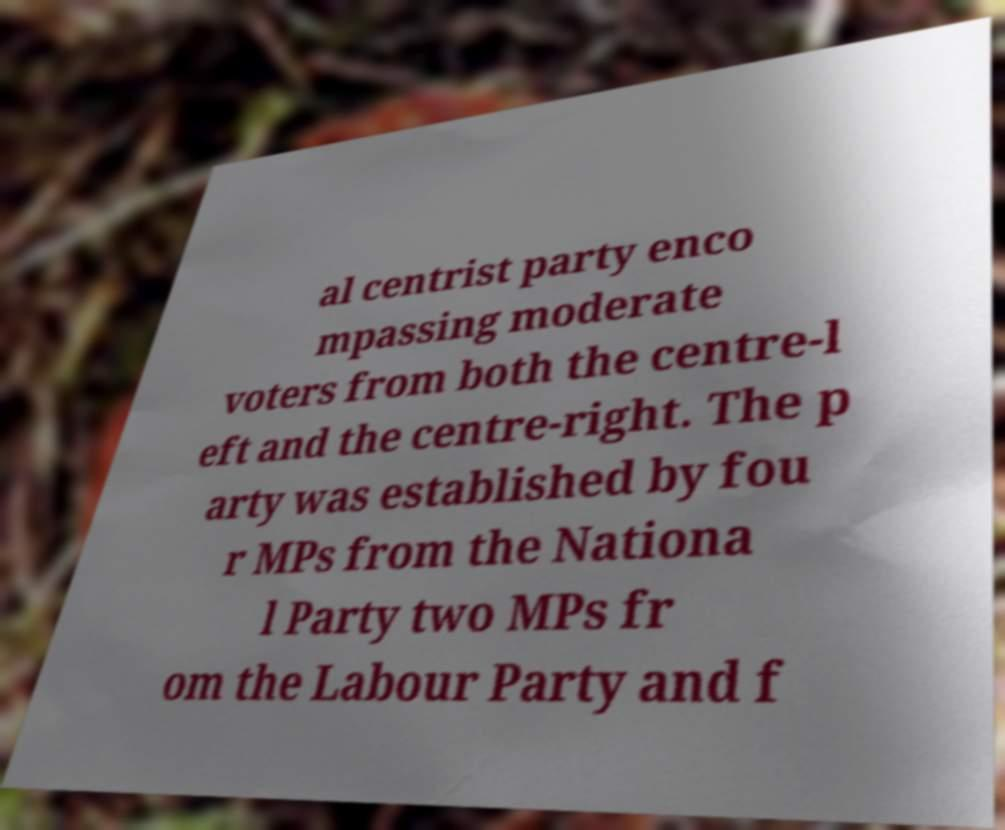Could you extract and type out the text from this image? al centrist party enco mpassing moderate voters from both the centre-l eft and the centre-right. The p arty was established by fou r MPs from the Nationa l Party two MPs fr om the Labour Party and f 